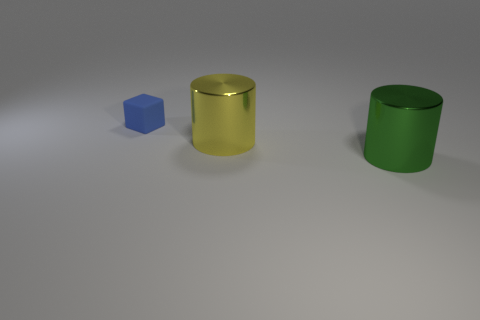What is the shape of the blue matte thing?
Make the answer very short. Cube. There is a green object that is the same size as the yellow shiny object; what is its material?
Your answer should be very brief. Metal. Are there any other things that have the same size as the blue object?
Offer a terse response. No. What number of things are either large objects or large yellow shiny things that are left of the green metal cylinder?
Your answer should be very brief. 2. The other cylinder that is made of the same material as the green cylinder is what size?
Make the answer very short. Large. The big thing that is on the right side of the large cylinder that is behind the big green thing is what shape?
Offer a very short reply. Cylinder. There is a object that is behind the big green metal cylinder and in front of the blue cube; what is its size?
Offer a terse response. Large. Is there another large thing that has the same shape as the green metal object?
Ensure brevity in your answer.  Yes. Are there any other things that are the same shape as the tiny blue thing?
Make the answer very short. No. The thing behind the shiny thing that is behind the large cylinder that is in front of the big yellow cylinder is made of what material?
Ensure brevity in your answer.  Rubber. 